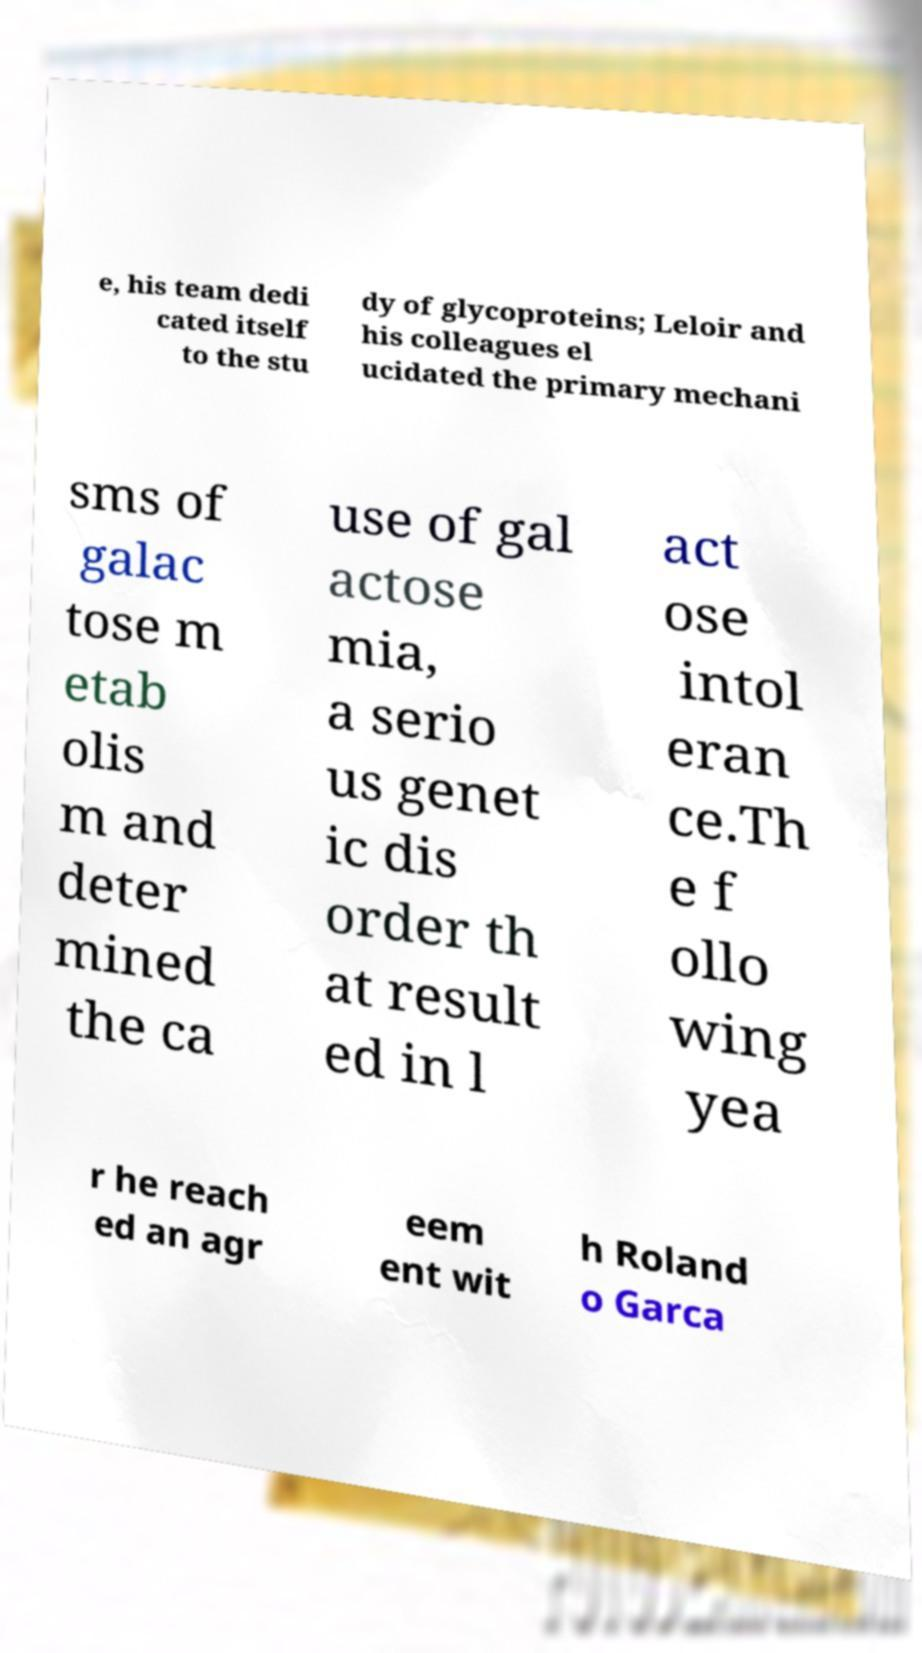Could you extract and type out the text from this image? e, his team dedi cated itself to the stu dy of glycoproteins; Leloir and his colleagues el ucidated the primary mechani sms of galac tose m etab olis m and deter mined the ca use of gal actose mia, a serio us genet ic dis order th at result ed in l act ose intol eran ce.Th e f ollo wing yea r he reach ed an agr eem ent wit h Roland o Garca 